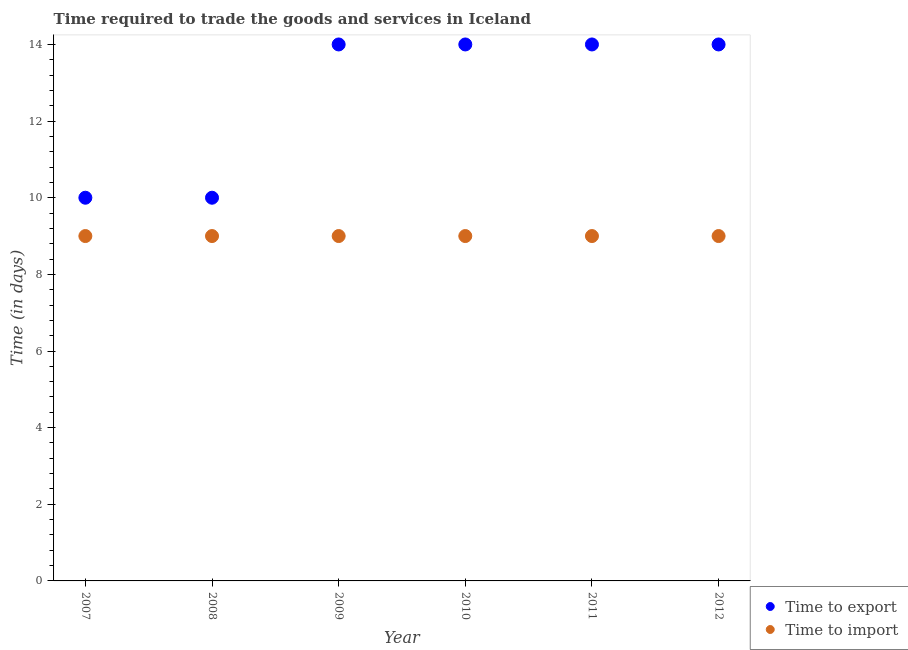What is the time to export in 2010?
Make the answer very short. 14. Across all years, what is the maximum time to import?
Give a very brief answer. 9. Across all years, what is the minimum time to import?
Offer a very short reply. 9. What is the total time to export in the graph?
Make the answer very short. 76. What is the difference between the time to export in 2007 and that in 2009?
Keep it short and to the point. -4. What is the difference between the time to import in 2010 and the time to export in 2008?
Keep it short and to the point. -1. What is the average time to export per year?
Ensure brevity in your answer.  12.67. In the year 2007, what is the difference between the time to export and time to import?
Provide a short and direct response. 1. In how many years, is the time to import greater than 4.4 days?
Provide a short and direct response. 6. What is the ratio of the time to import in 2008 to that in 2012?
Ensure brevity in your answer.  1. Is the time to import in 2008 less than that in 2011?
Your answer should be compact. No. What is the difference between the highest and the lowest time to export?
Provide a succinct answer. 4. In how many years, is the time to export greater than the average time to export taken over all years?
Provide a succinct answer. 4. Is the time to export strictly greater than the time to import over the years?
Keep it short and to the point. Yes. Are the values on the major ticks of Y-axis written in scientific E-notation?
Provide a succinct answer. No. Does the graph contain grids?
Offer a very short reply. No. What is the title of the graph?
Offer a terse response. Time required to trade the goods and services in Iceland. Does "Urban agglomerations" appear as one of the legend labels in the graph?
Your response must be concise. No. What is the label or title of the X-axis?
Your answer should be very brief. Year. What is the label or title of the Y-axis?
Provide a short and direct response. Time (in days). What is the Time (in days) in Time to import in 2007?
Your answer should be compact. 9. What is the Time (in days) in Time to export in 2008?
Ensure brevity in your answer.  10. What is the Time (in days) in Time to import in 2008?
Keep it short and to the point. 9. What is the Time (in days) of Time to export in 2010?
Your answer should be very brief. 14. What is the Time (in days) in Time to import in 2010?
Provide a short and direct response. 9. What is the Time (in days) in Time to export in 2011?
Provide a succinct answer. 14. What is the Time (in days) in Time to import in 2012?
Your answer should be compact. 9. Across all years, what is the maximum Time (in days) of Time to export?
Your answer should be very brief. 14. Across all years, what is the minimum Time (in days) of Time to export?
Your answer should be very brief. 10. What is the difference between the Time (in days) in Time to import in 2007 and that in 2009?
Provide a short and direct response. 0. What is the difference between the Time (in days) of Time to export in 2007 and that in 2010?
Give a very brief answer. -4. What is the difference between the Time (in days) in Time to import in 2007 and that in 2010?
Offer a very short reply. 0. What is the difference between the Time (in days) of Time to export in 2007 and that in 2011?
Offer a terse response. -4. What is the difference between the Time (in days) in Time to import in 2007 and that in 2011?
Keep it short and to the point. 0. What is the difference between the Time (in days) of Time to import in 2008 and that in 2009?
Your response must be concise. 0. What is the difference between the Time (in days) of Time to import in 2008 and that in 2010?
Your answer should be very brief. 0. What is the difference between the Time (in days) of Time to import in 2008 and that in 2011?
Ensure brevity in your answer.  0. What is the difference between the Time (in days) in Time to import in 2008 and that in 2012?
Your response must be concise. 0. What is the difference between the Time (in days) of Time to import in 2009 and that in 2010?
Your response must be concise. 0. What is the difference between the Time (in days) in Time to import in 2009 and that in 2011?
Ensure brevity in your answer.  0. What is the difference between the Time (in days) of Time to import in 2009 and that in 2012?
Make the answer very short. 0. What is the difference between the Time (in days) of Time to export in 2010 and that in 2011?
Offer a terse response. 0. What is the difference between the Time (in days) in Time to import in 2010 and that in 2011?
Make the answer very short. 0. What is the difference between the Time (in days) in Time to export in 2010 and that in 2012?
Give a very brief answer. 0. What is the difference between the Time (in days) in Time to import in 2010 and that in 2012?
Provide a succinct answer. 0. What is the difference between the Time (in days) of Time to export in 2007 and the Time (in days) of Time to import in 2009?
Your response must be concise. 1. What is the difference between the Time (in days) of Time to export in 2007 and the Time (in days) of Time to import in 2011?
Ensure brevity in your answer.  1. What is the difference between the Time (in days) of Time to export in 2009 and the Time (in days) of Time to import in 2011?
Make the answer very short. 5. What is the difference between the Time (in days) of Time to export in 2010 and the Time (in days) of Time to import in 2011?
Give a very brief answer. 5. What is the average Time (in days) of Time to export per year?
Provide a succinct answer. 12.67. What is the average Time (in days) of Time to import per year?
Your answer should be very brief. 9. In the year 2010, what is the difference between the Time (in days) in Time to export and Time (in days) in Time to import?
Your response must be concise. 5. What is the ratio of the Time (in days) of Time to export in 2007 to that in 2008?
Ensure brevity in your answer.  1. What is the ratio of the Time (in days) in Time to import in 2007 to that in 2008?
Your answer should be compact. 1. What is the ratio of the Time (in days) in Time to export in 2007 to that in 2009?
Keep it short and to the point. 0.71. What is the ratio of the Time (in days) in Time to import in 2007 to that in 2009?
Ensure brevity in your answer.  1. What is the ratio of the Time (in days) in Time to export in 2007 to that in 2010?
Your answer should be compact. 0.71. What is the ratio of the Time (in days) of Time to import in 2007 to that in 2011?
Provide a succinct answer. 1. What is the ratio of the Time (in days) of Time to export in 2007 to that in 2012?
Provide a succinct answer. 0.71. What is the ratio of the Time (in days) in Time to import in 2008 to that in 2009?
Offer a terse response. 1. What is the ratio of the Time (in days) of Time to export in 2008 to that in 2010?
Ensure brevity in your answer.  0.71. What is the ratio of the Time (in days) of Time to export in 2008 to that in 2011?
Provide a succinct answer. 0.71. What is the ratio of the Time (in days) of Time to import in 2008 to that in 2011?
Provide a succinct answer. 1. What is the ratio of the Time (in days) in Time to export in 2008 to that in 2012?
Keep it short and to the point. 0.71. What is the ratio of the Time (in days) of Time to import in 2009 to that in 2010?
Keep it short and to the point. 1. What is the ratio of the Time (in days) of Time to export in 2010 to that in 2011?
Provide a succinct answer. 1. What is the ratio of the Time (in days) in Time to import in 2011 to that in 2012?
Give a very brief answer. 1. What is the difference between the highest and the second highest Time (in days) of Time to export?
Your response must be concise. 0. What is the difference between the highest and the second highest Time (in days) in Time to import?
Make the answer very short. 0. 